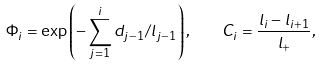Convert formula to latex. <formula><loc_0><loc_0><loc_500><loc_500>\Phi _ { i } = \exp \left ( - \sum _ { j = 1 } ^ { i } d _ { j - 1 } / l _ { j - 1 } \right ) , \quad C _ { i } = \frac { l _ { i } - l _ { i + 1 } } { l _ { + } } ,</formula> 